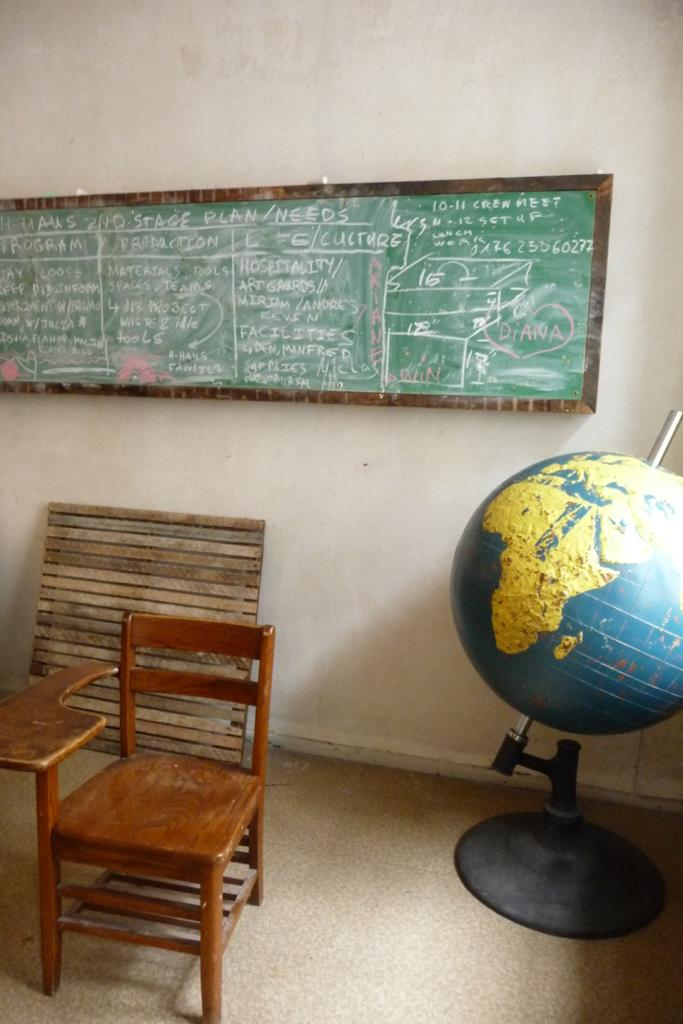What is on the wall in the center of the image? There is a board on the wall in the center of the image. What is located on the left side of the image? There is a table and a chair on the left side of the image. What type of polish is being applied to the horses in the image? There are no horses or polish present in the image. What is the wish that is granted in the image? There is no mention of a wish or any magical elements in the image. 